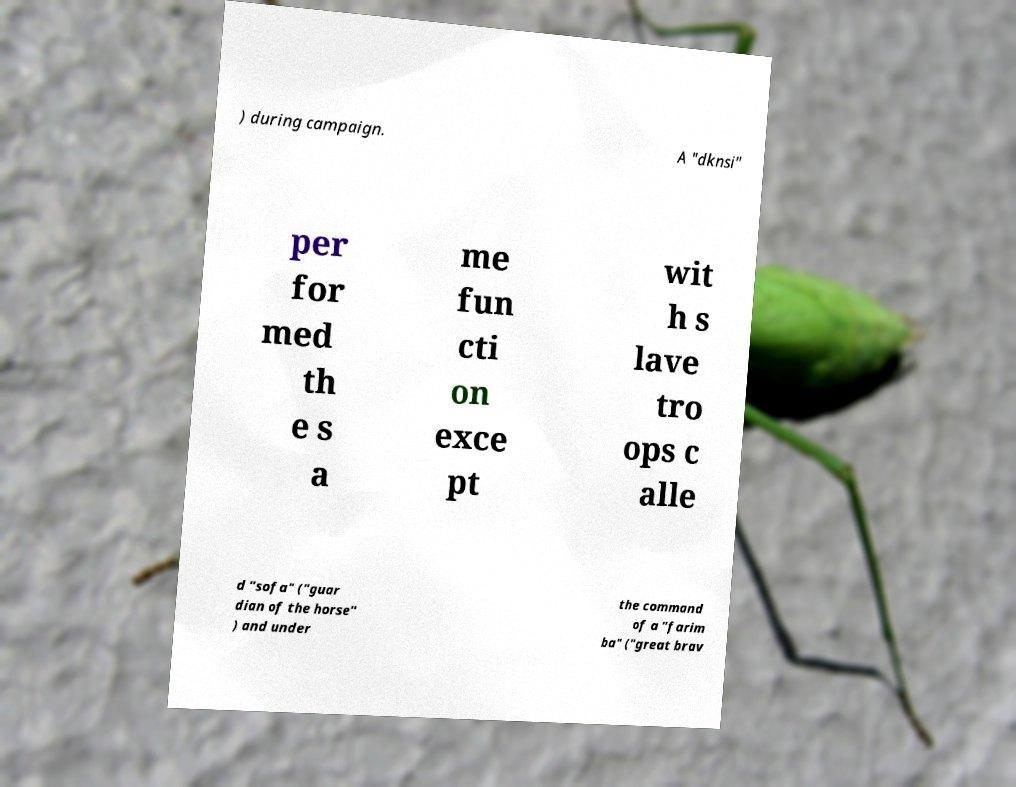What messages or text are displayed in this image? I need them in a readable, typed format. ) during campaign. A "dknsi" per for med th e s a me fun cti on exce pt wit h s lave tro ops c alle d "sofa" ("guar dian of the horse" ) and under the command of a "farim ba" ("great brav 